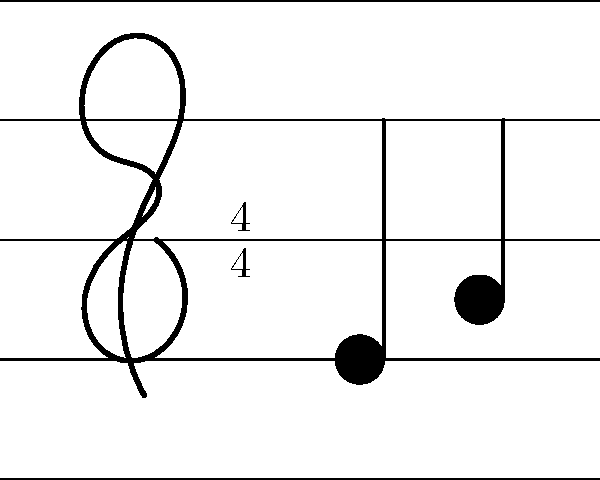Consider the musical staff notation shown in the image. What is the order of the symmetry group of this staff notation, considering only vertical reflections and 180-degree rotations? Let's approach this step-by-step:

1) First, we need to identify the symmetries of the musical staff notation:

   a) The staff lines themselves have a vertical reflection symmetry.
   b) The staff lines also have 180-degree rotational symmetry.

2) However, we need to consider the entire notation, including the treble clef, time signature, and notes:

   a) The treble clef breaks both the vertical reflection and 180-degree rotational symmetry.
   b) The time signature (4/4) has its own vertical symmetry but breaks the 180-degree rotational symmetry.
   c) The notes break both symmetries as well.

3) Given these observations, we can conclude:

   a) There is no vertical reflection symmetry for the entire notation.
   b) There is no 180-degree rotational symmetry for the entire notation.

4) In group theory, when an object has no symmetries other than the identity transformation (leaving it unchanged), we say it has the trivial symmetry group.

5) The trivial group contains only the identity element, so its order (number of elements) is 1.

Therefore, considering only vertical reflections and 180-degree rotations, the symmetry group of this musical staff notation is the trivial group, which has an order of 1.
Answer: 1 